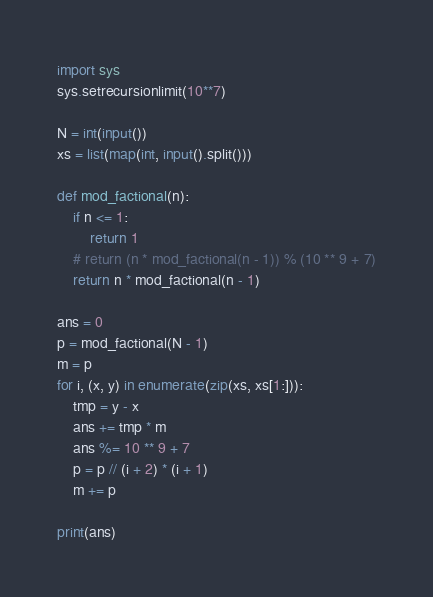<code> <loc_0><loc_0><loc_500><loc_500><_Python_>import sys
sys.setrecursionlimit(10**7)

N = int(input())
xs = list(map(int, input().split()))

def mod_factional(n):
    if n <= 1:
        return 1
    # return (n * mod_factional(n - 1)) % (10 ** 9 + 7)
    return n * mod_factional(n - 1)

ans = 0
p = mod_factional(N - 1)
m = p
for i, (x, y) in enumerate(zip(xs, xs[1:])):
    tmp = y - x
    ans += tmp * m
    ans %= 10 ** 9 + 7
    p = p // (i + 2) * (i + 1)
    m += p

print(ans)
</code> 